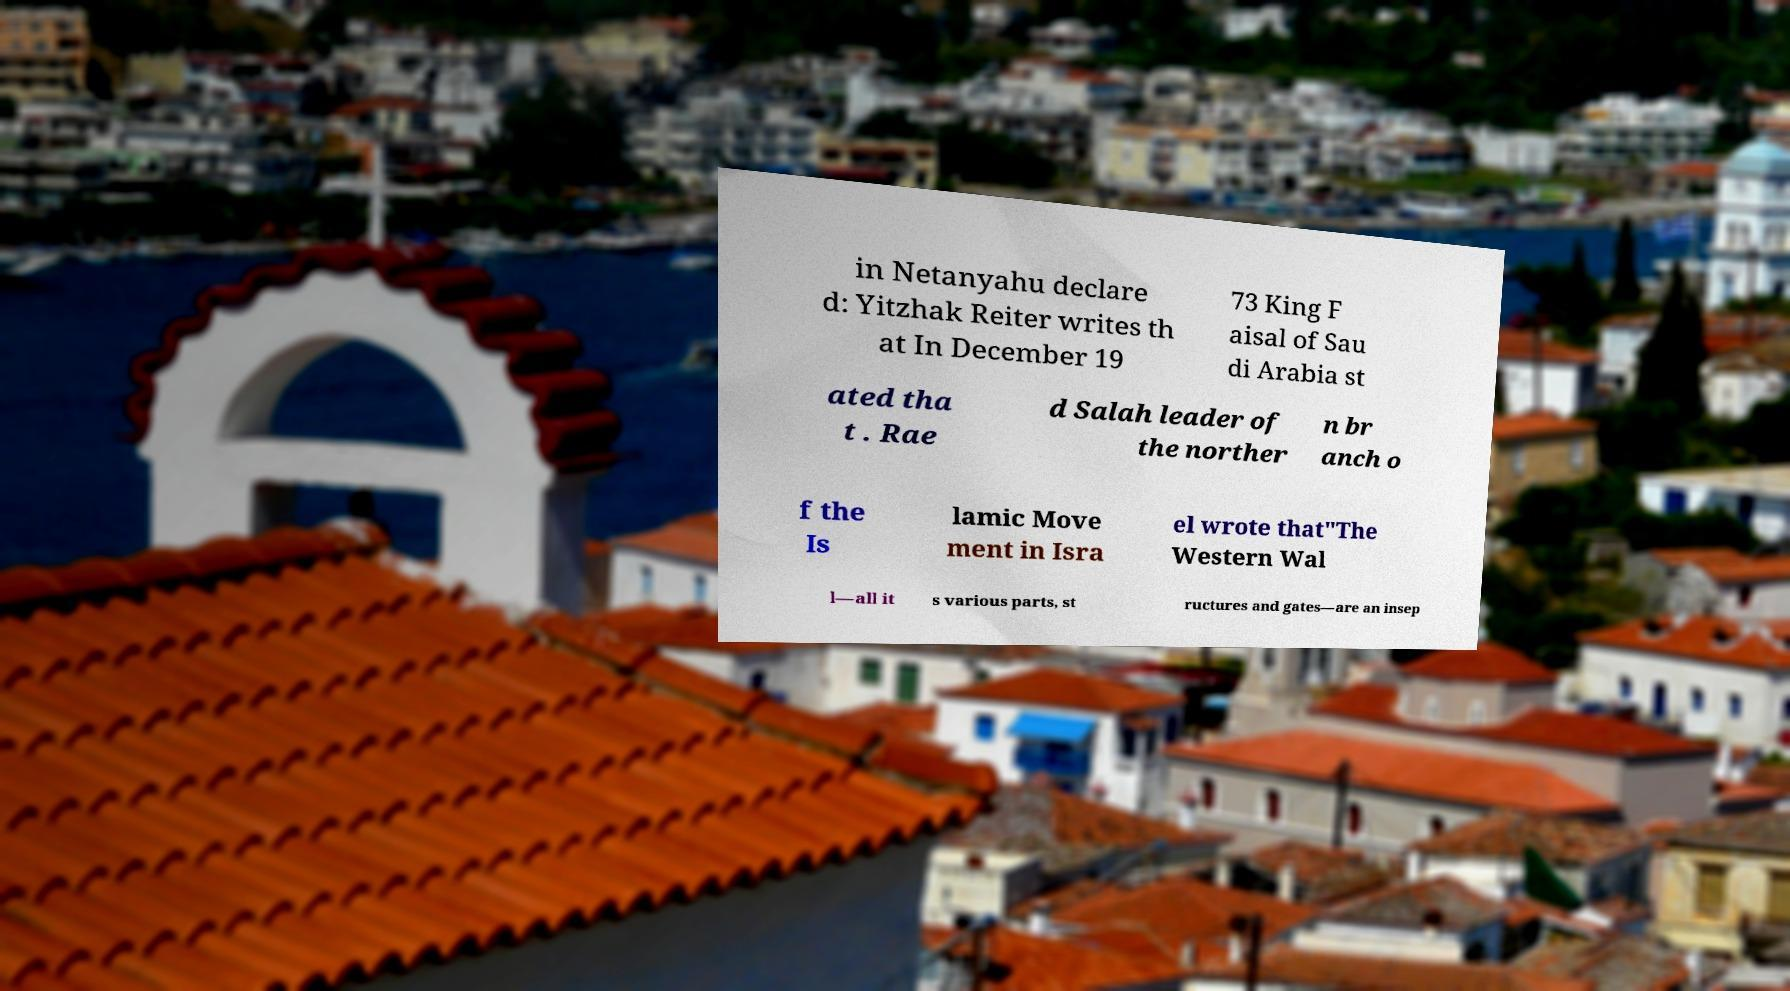Can you read and provide the text displayed in the image?This photo seems to have some interesting text. Can you extract and type it out for me? in Netanyahu declare d: Yitzhak Reiter writes th at In December 19 73 King F aisal of Sau di Arabia st ated tha t . Rae d Salah leader of the norther n br anch o f the Is lamic Move ment in Isra el wrote that"The Western Wal l—all it s various parts, st ructures and gates—are an insep 